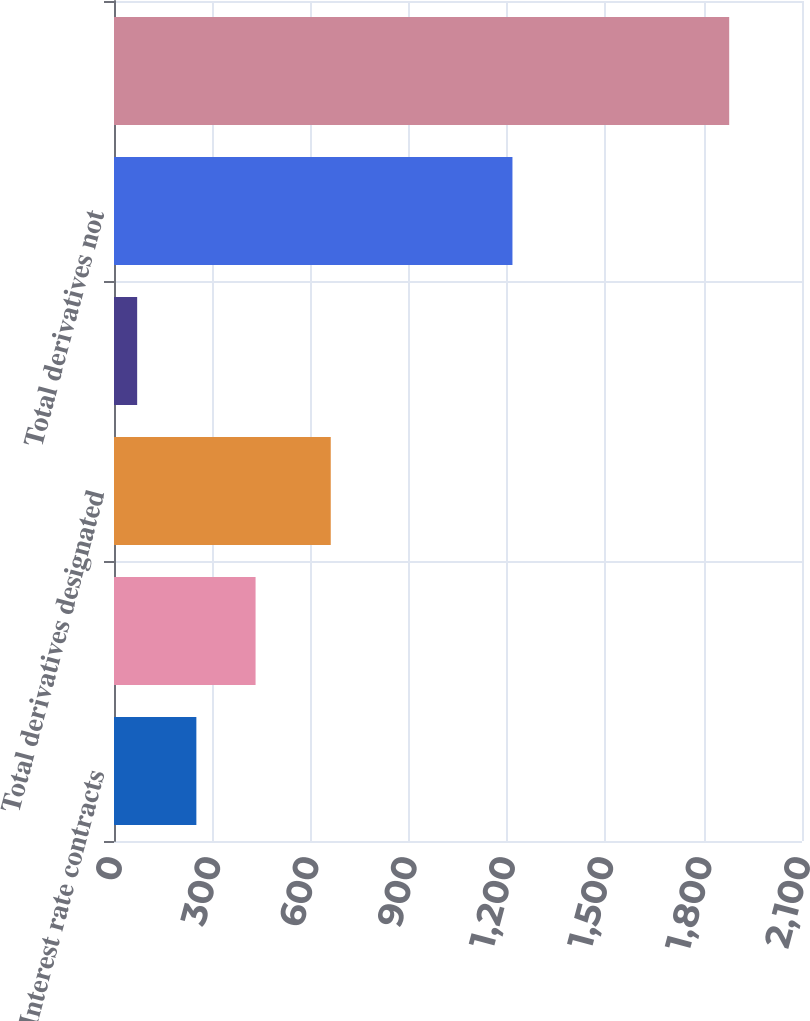Convert chart. <chart><loc_0><loc_0><loc_500><loc_500><bar_chart><fcel>Interest rate contracts<fcel>Foreign exchange contracts<fcel>Total derivatives designated<fcel>Credit contracts<fcel>Total derivatives not<fcel>Total derivative instruments<nl><fcel>251.41<fcel>432.12<fcel>661.6<fcel>70.7<fcel>1216.2<fcel>1877.8<nl></chart> 